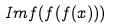<formula> <loc_0><loc_0><loc_500><loc_500>I m f ( f ( f ( x ) ) )</formula> 